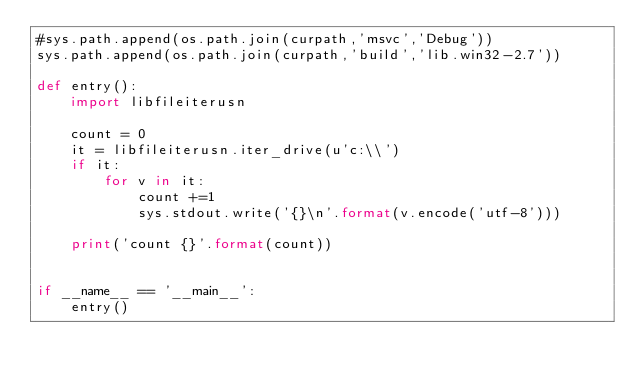Convert code to text. <code><loc_0><loc_0><loc_500><loc_500><_Python_>#sys.path.append(os.path.join(curpath,'msvc','Debug'))
sys.path.append(os.path.join(curpath,'build','lib.win32-2.7'))

def entry():
    import libfileiterusn

    count = 0
    it = libfileiterusn.iter_drive(u'c:\\')
    if it:
        for v in it:
            count +=1
            sys.stdout.write('{}\n'.format(v.encode('utf-8')))

    print('count {}'.format(count))


if __name__ == '__main__':
    entry()</code> 